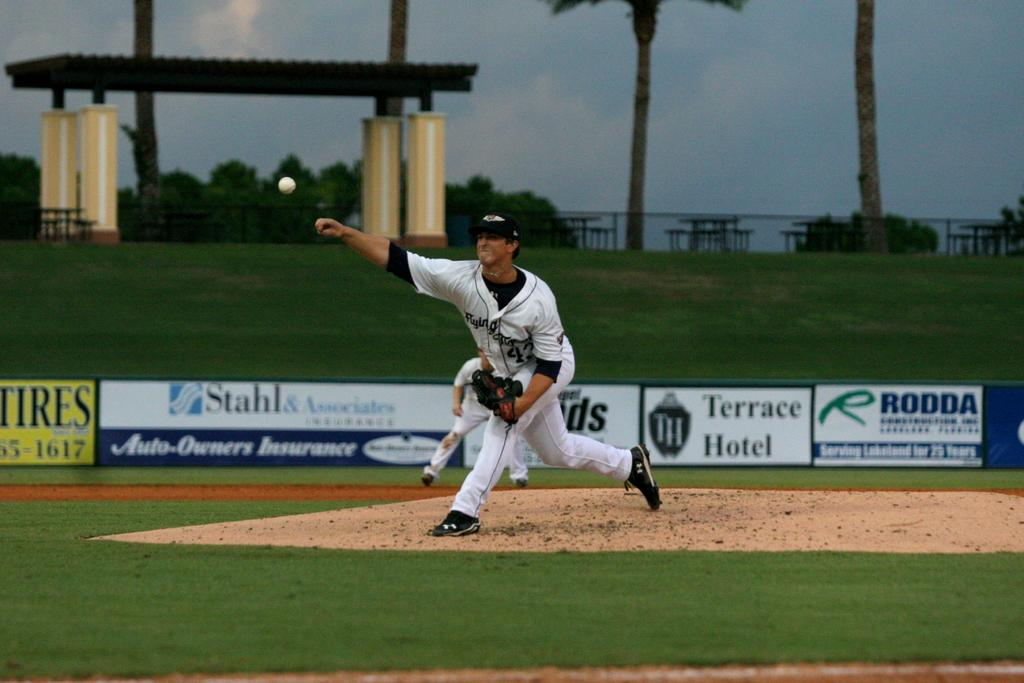<image>
Offer a succinct explanation of the picture presented. A baseball player has thrown a ball with ads in the background for RODDA, Terrace Hotel, Stahl & Associates Auto-Owners Insurance. 